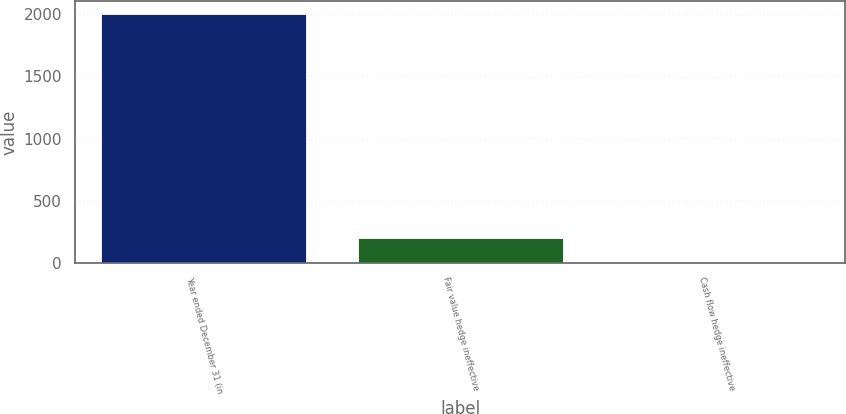Convert chart to OTSL. <chart><loc_0><loc_0><loc_500><loc_500><bar_chart><fcel>Year ended December 31 (in<fcel>Fair value hedge ineffective<fcel>Cash flow hedge ineffective<nl><fcel>2005<fcel>202.3<fcel>2<nl></chart> 